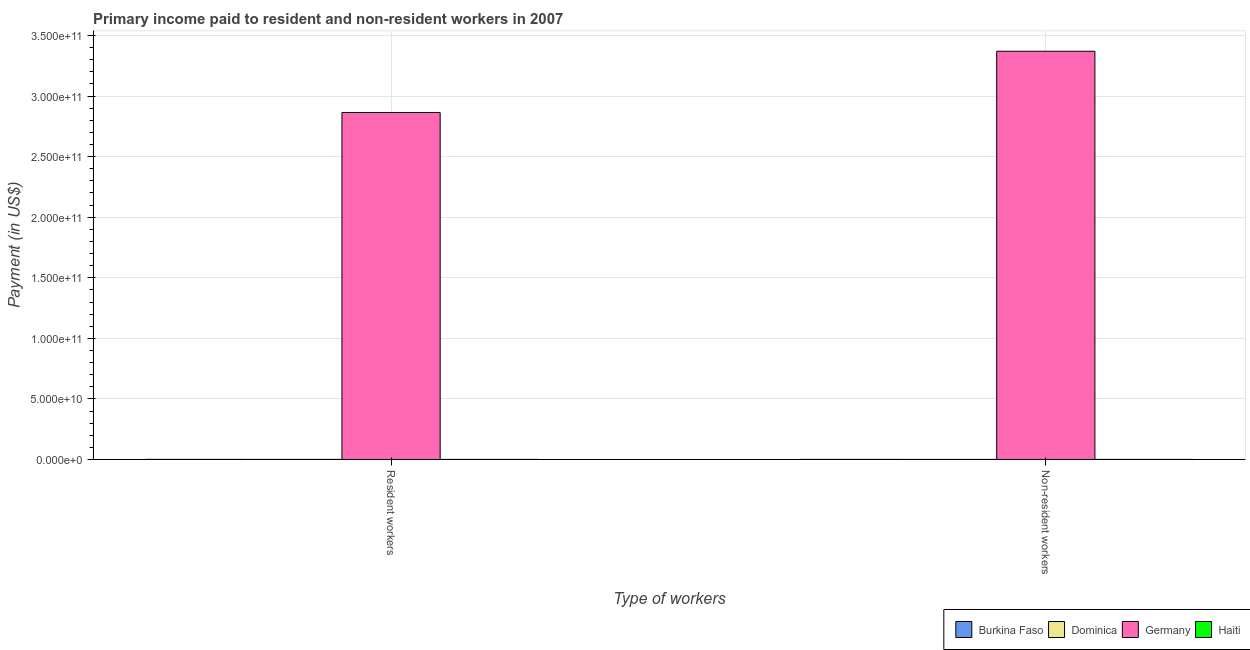How many different coloured bars are there?
Give a very brief answer. 4. How many groups of bars are there?
Offer a very short reply. 2. Are the number of bars per tick equal to the number of legend labels?
Your answer should be very brief. Yes. Are the number of bars on each tick of the X-axis equal?
Your answer should be very brief. Yes. How many bars are there on the 2nd tick from the left?
Give a very brief answer. 4. How many bars are there on the 2nd tick from the right?
Your answer should be compact. 4. What is the label of the 1st group of bars from the left?
Make the answer very short. Resident workers. What is the payment made to resident workers in Dominica?
Give a very brief answer. 2.82e+07. Across all countries, what is the maximum payment made to non-resident workers?
Your response must be concise. 3.37e+11. Across all countries, what is the minimum payment made to non-resident workers?
Keep it short and to the point. 8.54e+06. In which country was the payment made to non-resident workers maximum?
Provide a short and direct response. Germany. In which country was the payment made to resident workers minimum?
Your answer should be very brief. Haiti. What is the total payment made to resident workers in the graph?
Provide a succinct answer. 2.87e+11. What is the difference between the payment made to non-resident workers in Haiti and that in Burkina Faso?
Make the answer very short. -4.16e+07. What is the difference between the payment made to non-resident workers in Germany and the payment made to resident workers in Burkina Faso?
Offer a very short reply. 3.37e+11. What is the average payment made to non-resident workers per country?
Give a very brief answer. 8.43e+1. What is the difference between the payment made to resident workers and payment made to non-resident workers in Dominica?
Provide a succinct answer. 1.96e+07. In how many countries, is the payment made to resident workers greater than 200000000000 US$?
Offer a terse response. 1. What is the ratio of the payment made to non-resident workers in Burkina Faso to that in Haiti?
Give a very brief answer. 2.91. Is the payment made to resident workers in Dominica less than that in Haiti?
Make the answer very short. No. What does the 1st bar from the left in Resident workers represents?
Ensure brevity in your answer.  Burkina Faso. What does the 1st bar from the right in Resident workers represents?
Give a very brief answer. Haiti. How many countries are there in the graph?
Provide a succinct answer. 4. Does the graph contain any zero values?
Give a very brief answer. No. Where does the legend appear in the graph?
Give a very brief answer. Bottom right. How many legend labels are there?
Keep it short and to the point. 4. What is the title of the graph?
Give a very brief answer. Primary income paid to resident and non-resident workers in 2007. Does "French Polynesia" appear as one of the legend labels in the graph?
Provide a short and direct response. No. What is the label or title of the X-axis?
Provide a short and direct response. Type of workers. What is the label or title of the Y-axis?
Your response must be concise. Payment (in US$). What is the Payment (in US$) of Burkina Faso in Resident workers?
Offer a very short reply. 6.57e+07. What is the Payment (in US$) of Dominica in Resident workers?
Provide a succinct answer. 2.82e+07. What is the Payment (in US$) of Germany in Resident workers?
Give a very brief answer. 2.86e+11. What is the Payment (in US$) in Haiti in Resident workers?
Offer a very short reply. 1.96e+07. What is the Payment (in US$) in Burkina Faso in Non-resident workers?
Provide a short and direct response. 6.34e+07. What is the Payment (in US$) in Dominica in Non-resident workers?
Your response must be concise. 8.54e+06. What is the Payment (in US$) in Germany in Non-resident workers?
Ensure brevity in your answer.  3.37e+11. What is the Payment (in US$) in Haiti in Non-resident workers?
Your response must be concise. 2.18e+07. Across all Type of workers, what is the maximum Payment (in US$) of Burkina Faso?
Provide a succinct answer. 6.57e+07. Across all Type of workers, what is the maximum Payment (in US$) in Dominica?
Provide a succinct answer. 2.82e+07. Across all Type of workers, what is the maximum Payment (in US$) of Germany?
Your answer should be very brief. 3.37e+11. Across all Type of workers, what is the maximum Payment (in US$) in Haiti?
Provide a succinct answer. 2.18e+07. Across all Type of workers, what is the minimum Payment (in US$) in Burkina Faso?
Your response must be concise. 6.34e+07. Across all Type of workers, what is the minimum Payment (in US$) of Dominica?
Offer a terse response. 8.54e+06. Across all Type of workers, what is the minimum Payment (in US$) in Germany?
Ensure brevity in your answer.  2.86e+11. Across all Type of workers, what is the minimum Payment (in US$) in Haiti?
Your answer should be very brief. 1.96e+07. What is the total Payment (in US$) of Burkina Faso in the graph?
Offer a terse response. 1.29e+08. What is the total Payment (in US$) in Dominica in the graph?
Provide a succinct answer. 3.67e+07. What is the total Payment (in US$) of Germany in the graph?
Provide a succinct answer. 6.23e+11. What is the total Payment (in US$) of Haiti in the graph?
Your answer should be very brief. 4.14e+07. What is the difference between the Payment (in US$) in Burkina Faso in Resident workers and that in Non-resident workers?
Give a very brief answer. 2.35e+06. What is the difference between the Payment (in US$) in Dominica in Resident workers and that in Non-resident workers?
Keep it short and to the point. 1.96e+07. What is the difference between the Payment (in US$) in Germany in Resident workers and that in Non-resident workers?
Ensure brevity in your answer.  -5.06e+1. What is the difference between the Payment (in US$) of Haiti in Resident workers and that in Non-resident workers?
Offer a terse response. -2.21e+06. What is the difference between the Payment (in US$) of Burkina Faso in Resident workers and the Payment (in US$) of Dominica in Non-resident workers?
Provide a short and direct response. 5.72e+07. What is the difference between the Payment (in US$) of Burkina Faso in Resident workers and the Payment (in US$) of Germany in Non-resident workers?
Your answer should be compact. -3.37e+11. What is the difference between the Payment (in US$) in Burkina Faso in Resident workers and the Payment (in US$) in Haiti in Non-resident workers?
Give a very brief answer. 4.39e+07. What is the difference between the Payment (in US$) of Dominica in Resident workers and the Payment (in US$) of Germany in Non-resident workers?
Give a very brief answer. -3.37e+11. What is the difference between the Payment (in US$) of Dominica in Resident workers and the Payment (in US$) of Haiti in Non-resident workers?
Make the answer very short. 6.36e+06. What is the difference between the Payment (in US$) of Germany in Resident workers and the Payment (in US$) of Haiti in Non-resident workers?
Provide a succinct answer. 2.86e+11. What is the average Payment (in US$) of Burkina Faso per Type of workers?
Make the answer very short. 6.45e+07. What is the average Payment (in US$) of Dominica per Type of workers?
Ensure brevity in your answer.  1.83e+07. What is the average Payment (in US$) of Germany per Type of workers?
Make the answer very short. 3.12e+11. What is the average Payment (in US$) in Haiti per Type of workers?
Your answer should be very brief. 2.07e+07. What is the difference between the Payment (in US$) of Burkina Faso and Payment (in US$) of Dominica in Resident workers?
Keep it short and to the point. 3.76e+07. What is the difference between the Payment (in US$) of Burkina Faso and Payment (in US$) of Germany in Resident workers?
Provide a short and direct response. -2.86e+11. What is the difference between the Payment (in US$) in Burkina Faso and Payment (in US$) in Haiti in Resident workers?
Ensure brevity in your answer.  4.61e+07. What is the difference between the Payment (in US$) in Dominica and Payment (in US$) in Germany in Resident workers?
Ensure brevity in your answer.  -2.86e+11. What is the difference between the Payment (in US$) of Dominica and Payment (in US$) of Haiti in Resident workers?
Ensure brevity in your answer.  8.56e+06. What is the difference between the Payment (in US$) of Germany and Payment (in US$) of Haiti in Resident workers?
Provide a short and direct response. 2.86e+11. What is the difference between the Payment (in US$) in Burkina Faso and Payment (in US$) in Dominica in Non-resident workers?
Offer a very short reply. 5.48e+07. What is the difference between the Payment (in US$) in Burkina Faso and Payment (in US$) in Germany in Non-resident workers?
Ensure brevity in your answer.  -3.37e+11. What is the difference between the Payment (in US$) of Burkina Faso and Payment (in US$) of Haiti in Non-resident workers?
Keep it short and to the point. 4.16e+07. What is the difference between the Payment (in US$) of Dominica and Payment (in US$) of Germany in Non-resident workers?
Make the answer very short. -3.37e+11. What is the difference between the Payment (in US$) in Dominica and Payment (in US$) in Haiti in Non-resident workers?
Offer a terse response. -1.33e+07. What is the difference between the Payment (in US$) in Germany and Payment (in US$) in Haiti in Non-resident workers?
Your answer should be very brief. 3.37e+11. What is the ratio of the Payment (in US$) in Dominica in Resident workers to that in Non-resident workers?
Offer a very short reply. 3.3. What is the ratio of the Payment (in US$) of Germany in Resident workers to that in Non-resident workers?
Offer a terse response. 0.85. What is the ratio of the Payment (in US$) of Haiti in Resident workers to that in Non-resident workers?
Provide a succinct answer. 0.9. What is the difference between the highest and the second highest Payment (in US$) in Burkina Faso?
Your answer should be very brief. 2.35e+06. What is the difference between the highest and the second highest Payment (in US$) in Dominica?
Ensure brevity in your answer.  1.96e+07. What is the difference between the highest and the second highest Payment (in US$) of Germany?
Your answer should be compact. 5.06e+1. What is the difference between the highest and the second highest Payment (in US$) of Haiti?
Make the answer very short. 2.21e+06. What is the difference between the highest and the lowest Payment (in US$) of Burkina Faso?
Keep it short and to the point. 2.35e+06. What is the difference between the highest and the lowest Payment (in US$) in Dominica?
Your answer should be compact. 1.96e+07. What is the difference between the highest and the lowest Payment (in US$) in Germany?
Ensure brevity in your answer.  5.06e+1. What is the difference between the highest and the lowest Payment (in US$) of Haiti?
Provide a succinct answer. 2.21e+06. 